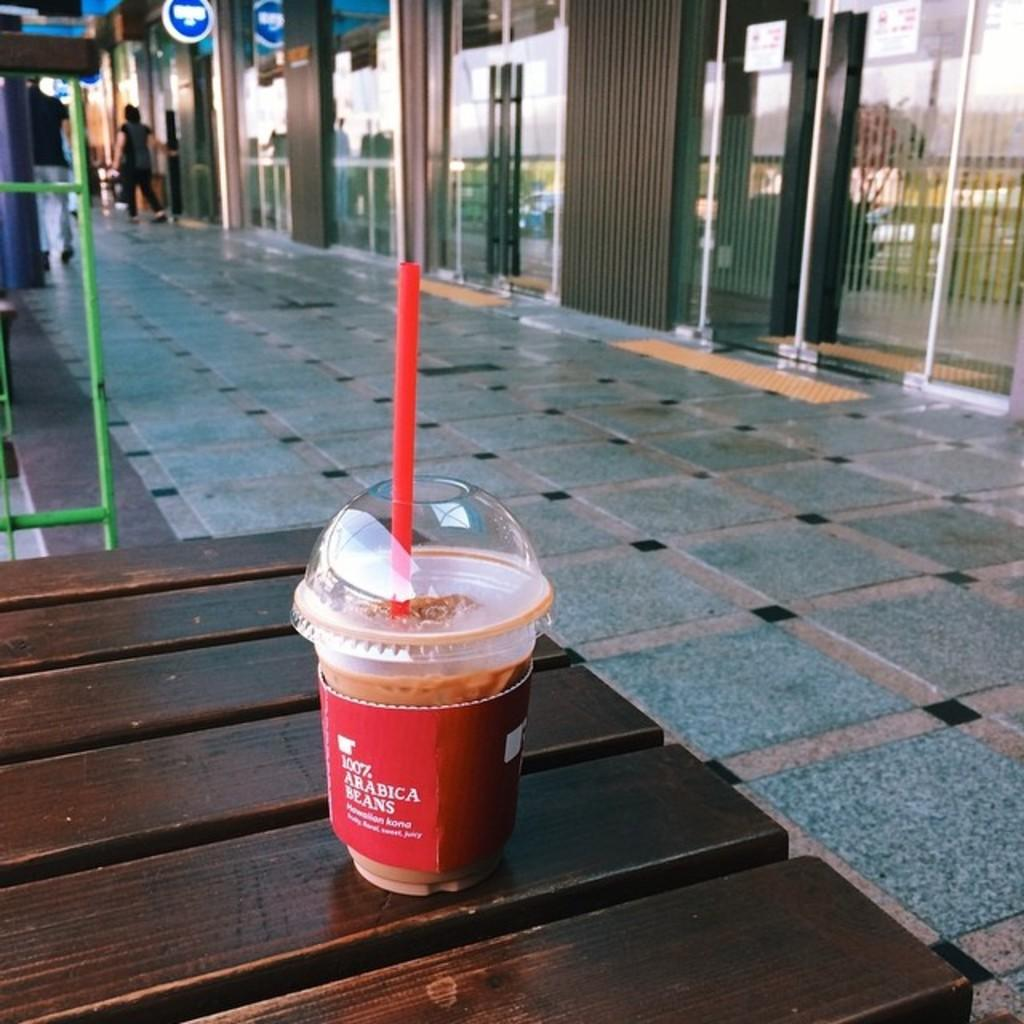What type of structures are visible in the image? There are buildings in the image. Are there any living beings present in the image? Yes, there are people in the image. What piece of furniture can be seen in the image? There is a table in the image. What object is placed on the table? There is a glass on the table. Where is the stove located in the image? There is no stove present in the image. What type of tool is being used by the people in the image? The provided facts do not mention any tools, such as a hammer, being used by the people in the image. 